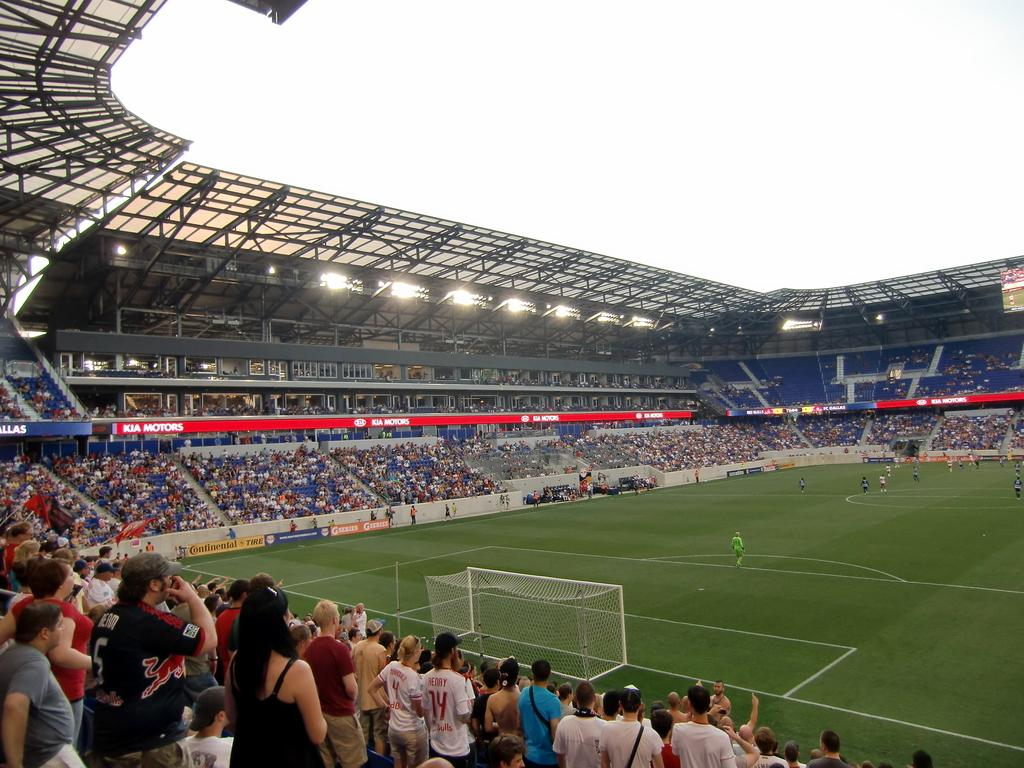<image>
Create a compact narrative representing the image presented. A soccer field with Kia Motors ads all around. 